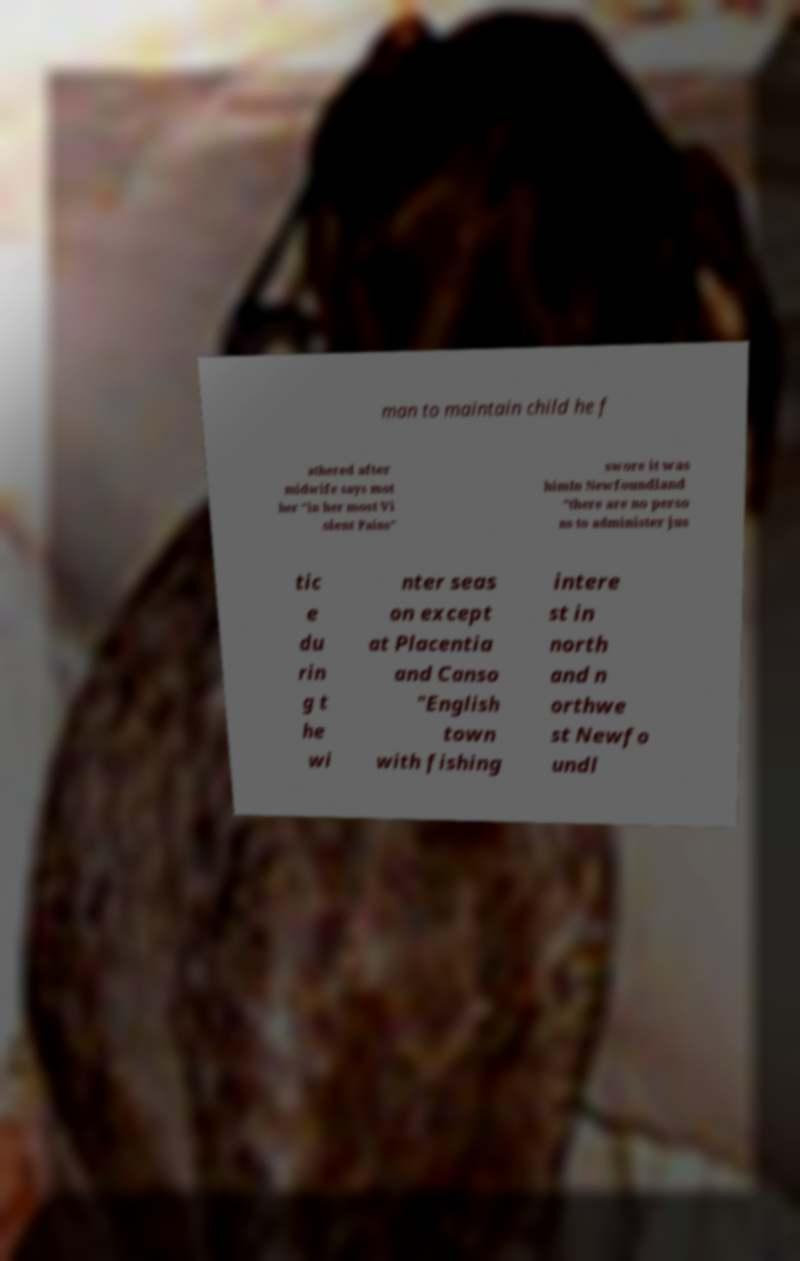For documentation purposes, I need the text within this image transcribed. Could you provide that? man to maintain child he f athered after midwife says mot her "in her most Vi olent Pains" swore it was himIn Newfoundland "there are no perso ns to administer jus tic e du rin g t he wi nter seas on except at Placentia and Canso "English town with fishing intere st in north and n orthwe st Newfo undl 